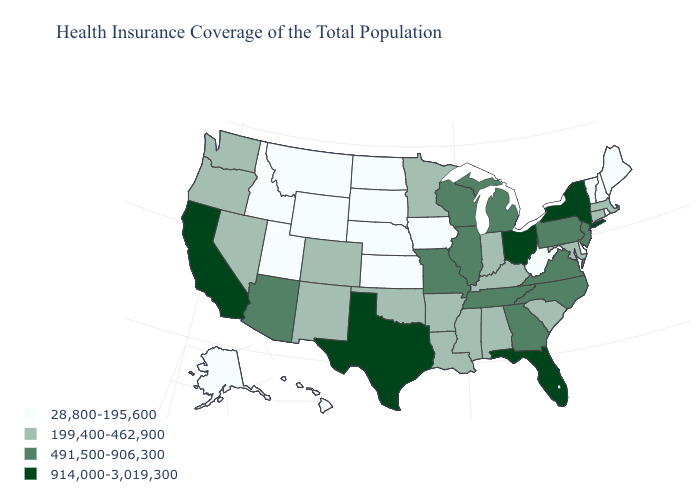How many symbols are there in the legend?
Give a very brief answer. 4. How many symbols are there in the legend?
Keep it brief. 4. Name the states that have a value in the range 491,500-906,300?
Write a very short answer. Arizona, Georgia, Illinois, Michigan, Missouri, New Jersey, North Carolina, Pennsylvania, Tennessee, Virginia, Wisconsin. Does California have the highest value in the West?
Give a very brief answer. Yes. What is the highest value in the USA?
Write a very short answer. 914,000-3,019,300. Does Missouri have a higher value than Maryland?
Write a very short answer. Yes. What is the value of South Carolina?
Answer briefly. 199,400-462,900. What is the highest value in the USA?
Short answer required. 914,000-3,019,300. Does Illinois have the same value as Arizona?
Keep it brief. Yes. Does Maine have the same value as Nebraska?
Quick response, please. Yes. Which states have the highest value in the USA?
Give a very brief answer. California, Florida, New York, Ohio, Texas. What is the lowest value in the USA?
Write a very short answer. 28,800-195,600. Does Florida have the same value as New York?
Give a very brief answer. Yes. What is the highest value in the West ?
Answer briefly. 914,000-3,019,300. 